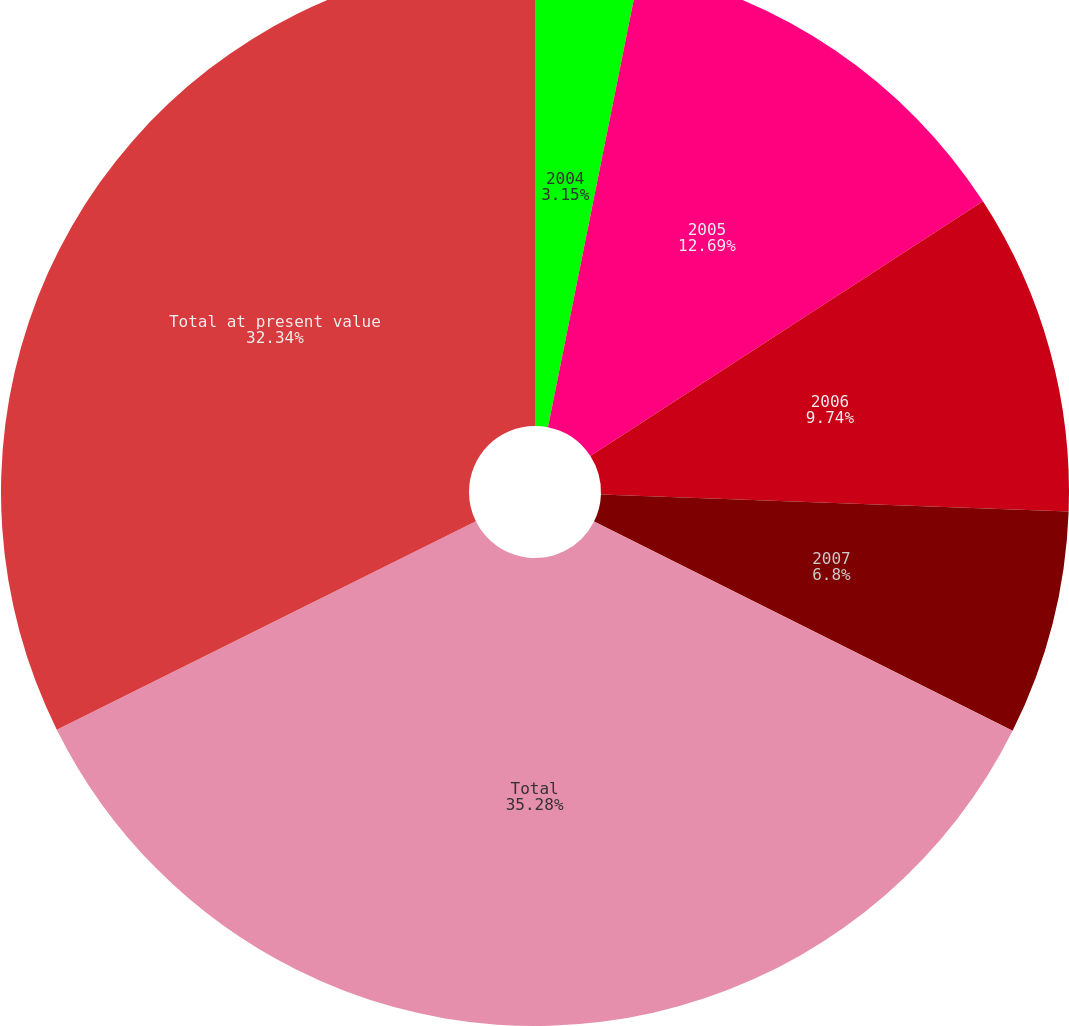Convert chart. <chart><loc_0><loc_0><loc_500><loc_500><pie_chart><fcel>2004<fcel>2005<fcel>2006<fcel>2007<fcel>Total<fcel>Total at present value<nl><fcel>3.15%<fcel>12.69%<fcel>9.74%<fcel>6.8%<fcel>35.28%<fcel>32.34%<nl></chart> 